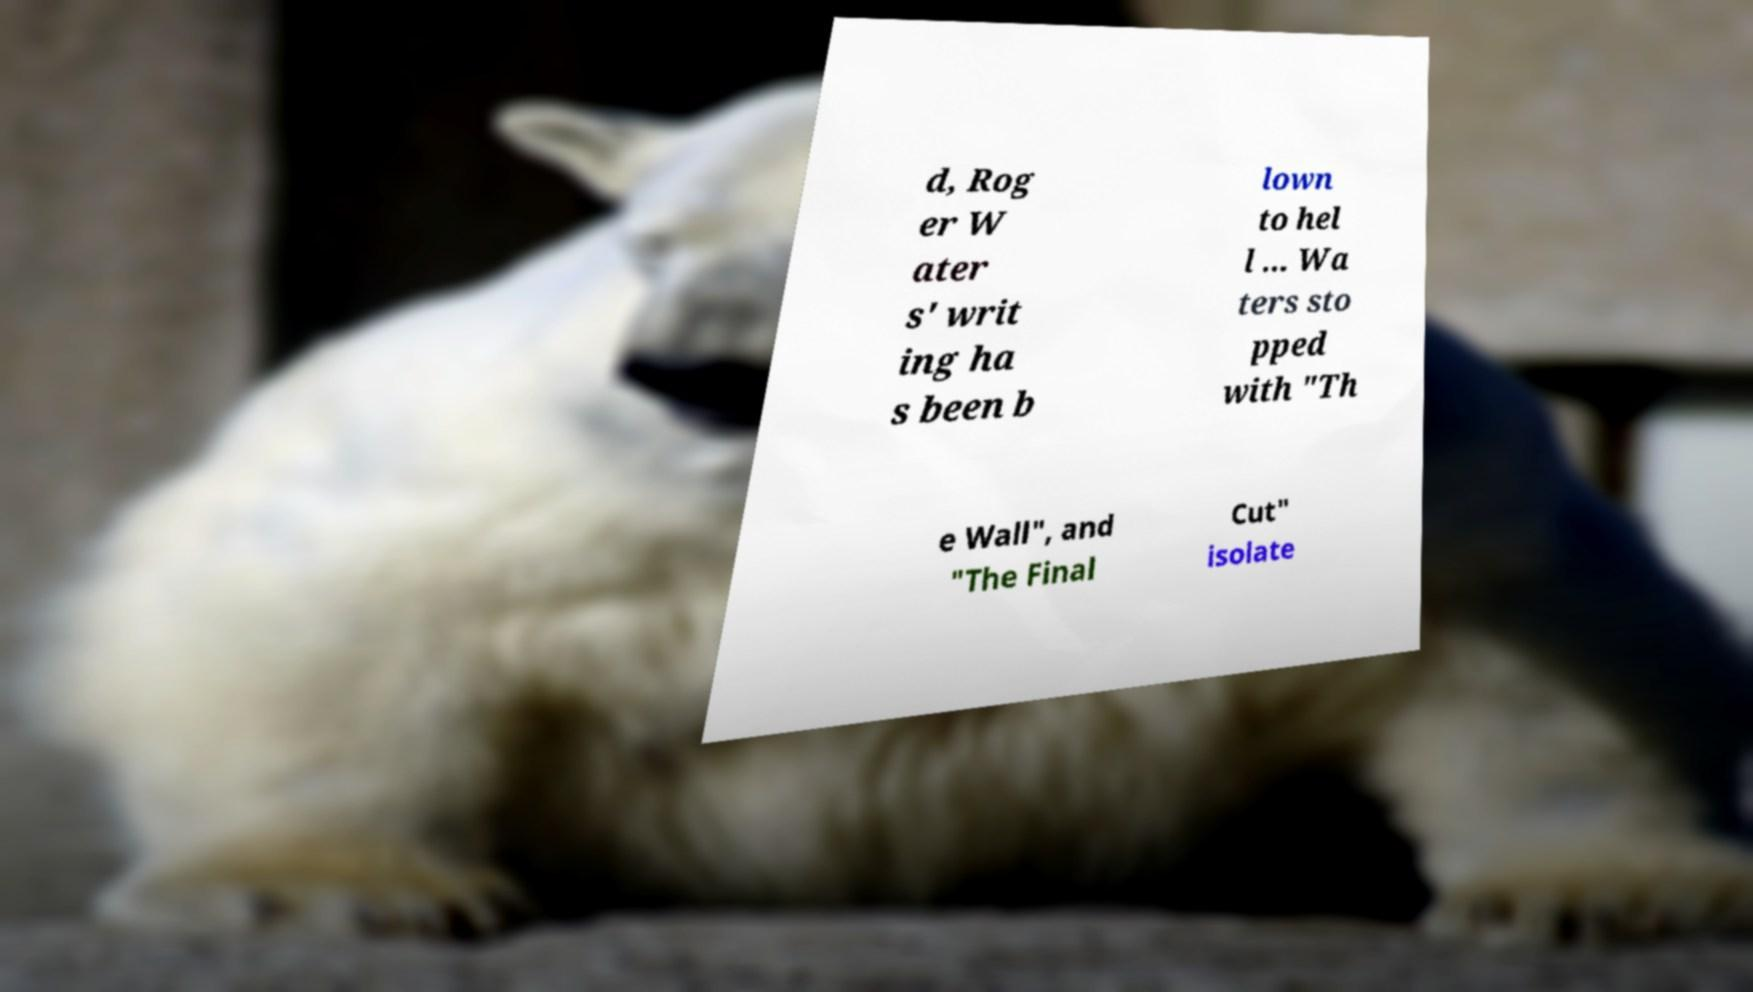Can you read and provide the text displayed in the image?This photo seems to have some interesting text. Can you extract and type it out for me? d, Rog er W ater s' writ ing ha s been b lown to hel l ... Wa ters sto pped with "Th e Wall", and "The Final Cut" isolate 